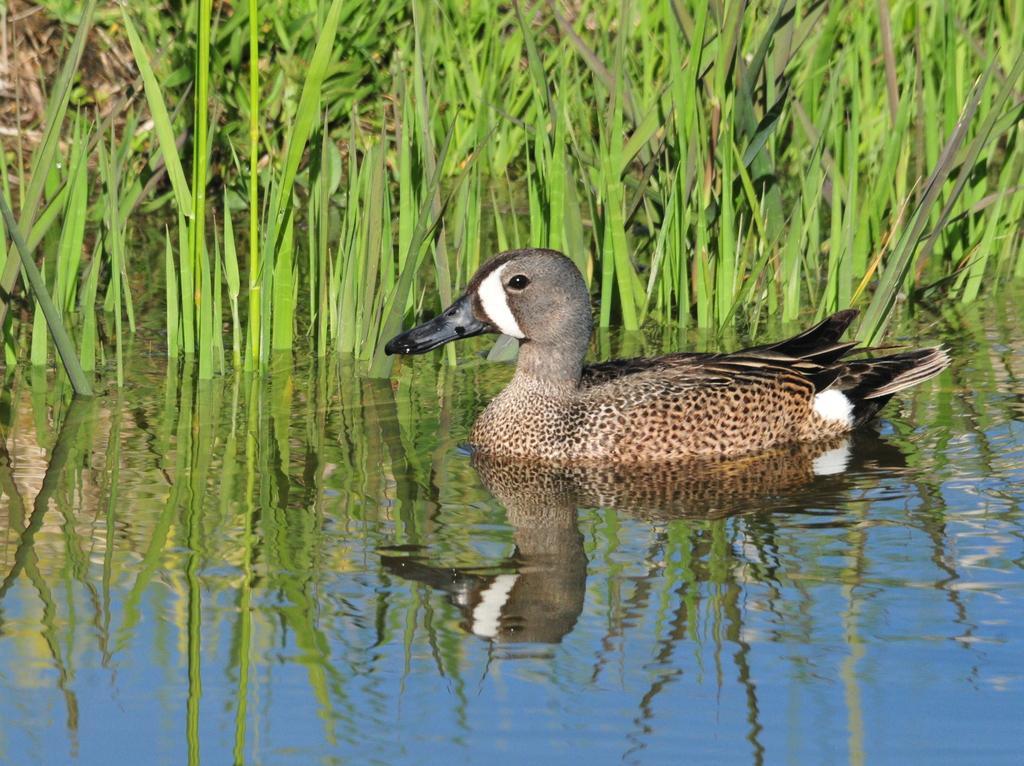Please provide a concise description of this image. In this picture we can see there is a duck in the water. Behind the duck there are plants. On the water, we can see the reflection of the sky. 